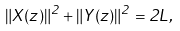Convert formula to latex. <formula><loc_0><loc_0><loc_500><loc_500>\| X ( z ) \| ^ { 2 } + \| Y ( z ) \| ^ { 2 } = 2 L ,</formula> 